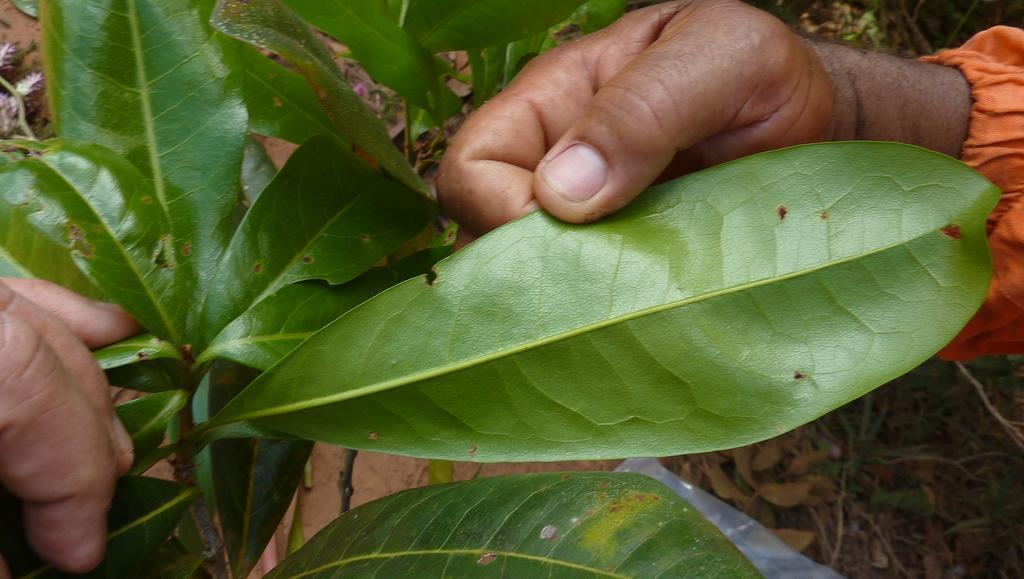Please provide a concise description of this image. Here I can see a person's hands holding the leaves of a plant. On the right bottom of the image I can see the ground. 